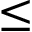Convert formula to latex. <formula><loc_0><loc_0><loc_500><loc_500>\leq</formula> 